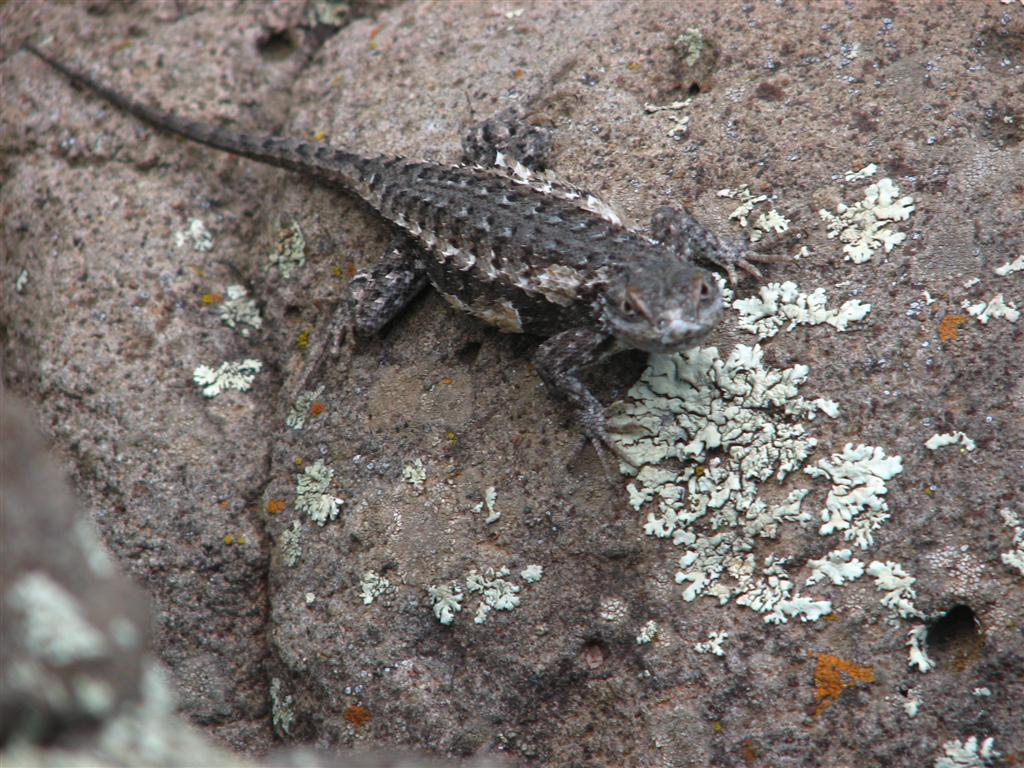What type of animal is in the image? There is a lizard in the image. What is the lizard doing in the image? The lizard is on a surface. What is the reaction of the lizard to the passing trains in the image? There are no trains present in the image, so the lizard's reaction to them cannot be determined. 